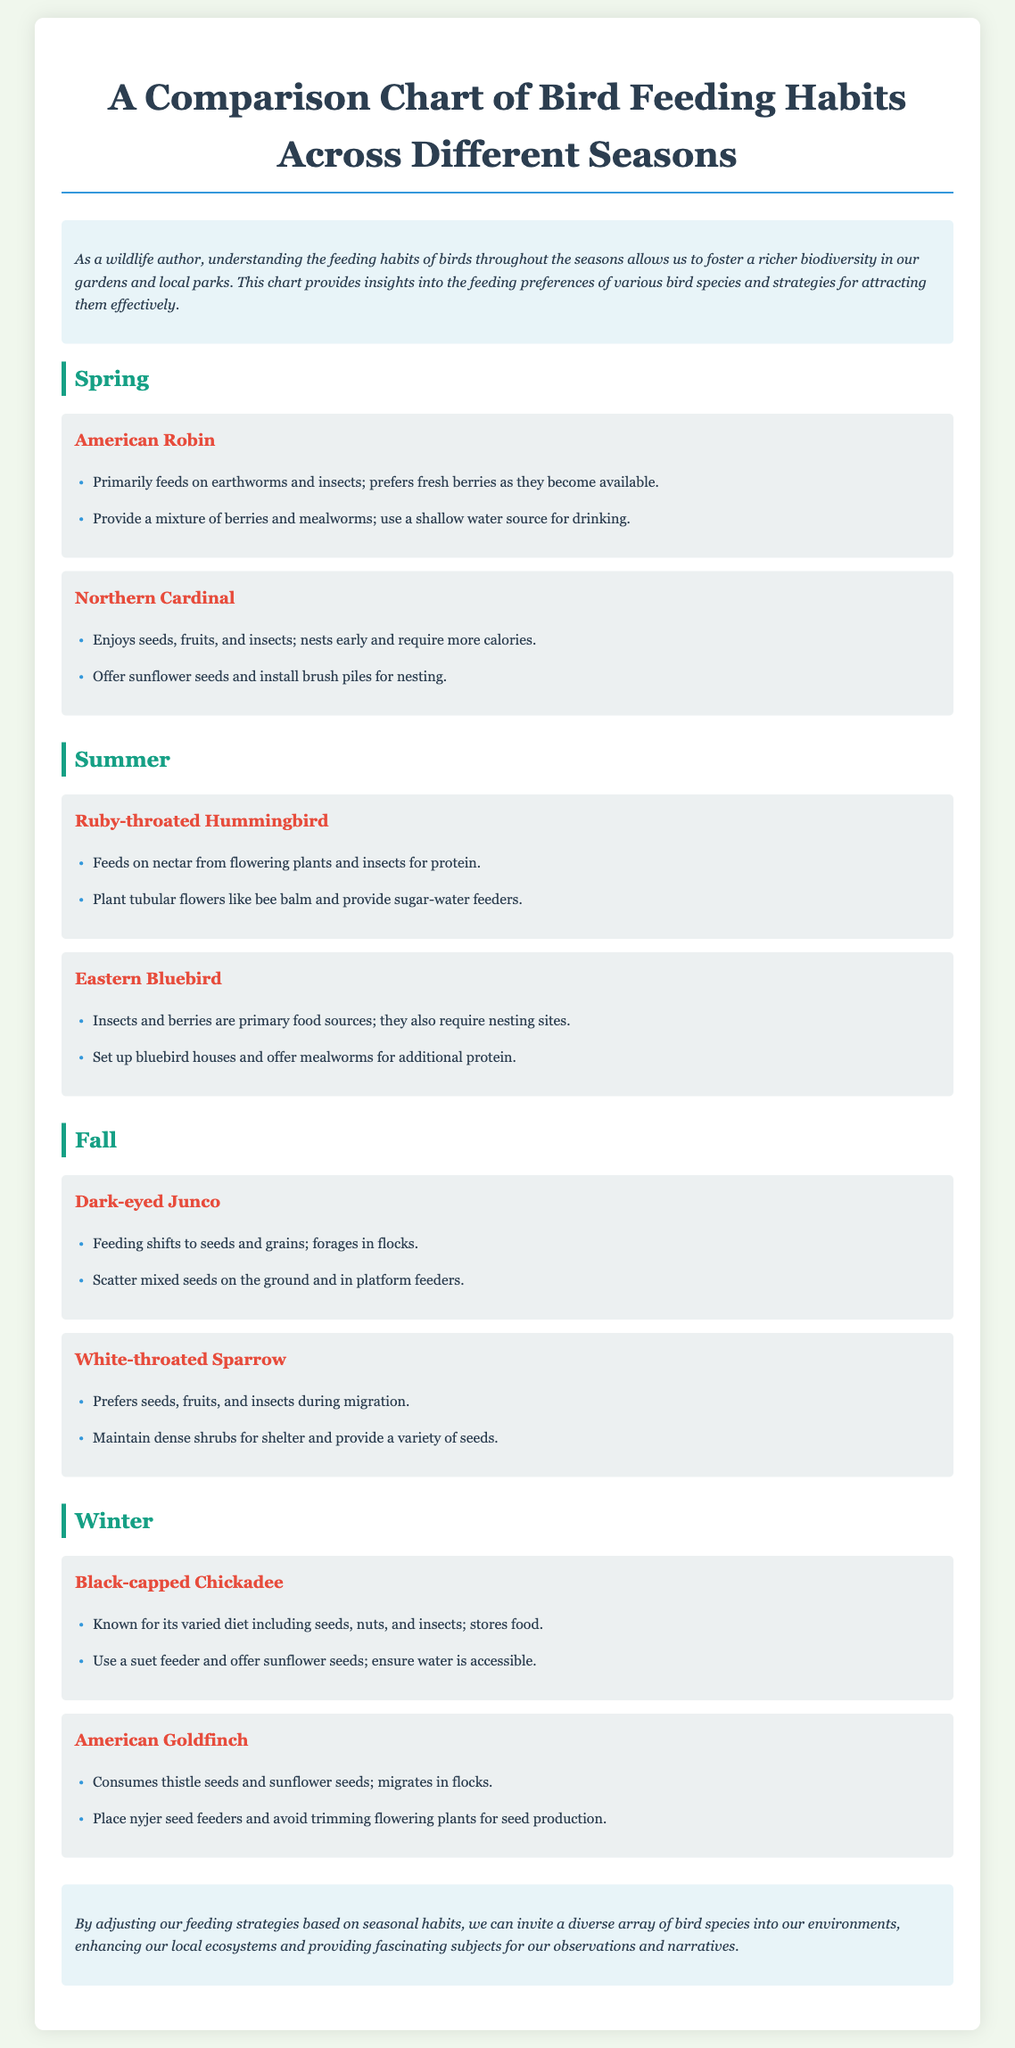What is the primary food source for the American Robin in spring? The document states that the American Robin primarily feeds on earthworms and insects in spring.
Answer: earthworms and insects What type of feeder is recommended for Black-capped Chickadee? The memo advises using a suet feeder for Black-capped Chickadee.
Answer: suet feeder Which bird species requires nesting sites in summer? The Eastern Bluebird requires nesting sites during the summer season.
Answer: Eastern Bluebird In which season do Dark-eyed Junco usually forage in flocks? The document indicates that Dark-eyed Junco forages in flocks during fall.
Answer: fall What is a suggested tip for attracting Northern Cardinal? The memo suggests offering sunflower seeds and installing brush piles for nesting to attract Northern Cardinal.
Answer: sunflower seeds and install brush piles How does the diet of birds change from summer to fall? Birds like Dark-eyed Junco shift their diet from insects and berries in summer to seeds and grains in fall.
Answer: seeds and grains What color is the header for the Spring section? The header for the Spring section is colored in a shade of teal, known as #16a085 in the document's CSS.
Answer: teal What should be avoided to support American Goldfinch? The document advises avoiding trimming flowering plants for seed production to support American Goldfinch.
Answer: avoiding trimming flowering plants Which season is associated with Ruby-throated Hummingbird? The Ruby-throated Hummingbird is associated with the summer season as noted in the memo.
Answer: summer 